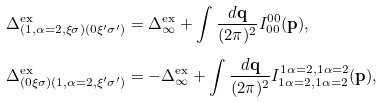<formula> <loc_0><loc_0><loc_500><loc_500>\Delta ^ { \text {ex} } _ { ( 1 , \alpha = 2 , \xi \sigma ) ( 0 \xi ^ { \prime } \sigma ^ { \prime } ) } & = \Delta ^ { \text {ex} } _ { \infty } + \int \frac { d \mathbf q } { ( 2 \pi ) ^ { 2 } } I ^ { 0 0 } _ { 0 0 } ( \mathbf p ) , \\ \Delta ^ { \text {ex} } _ { ( 0 \xi \sigma ) ( 1 , \alpha = 2 , \xi ^ { \prime } \sigma ^ { \prime } ) } & = - \Delta ^ { \text {ex} } _ { \infty } + \int \frac { d \mathbf q } { ( 2 \pi ) ^ { 2 } } I ^ { 1 \alpha = 2 , 1 \alpha = 2 } _ { 1 \alpha = 2 , 1 \alpha = 2 } ( \mathbf p ) ,</formula> 